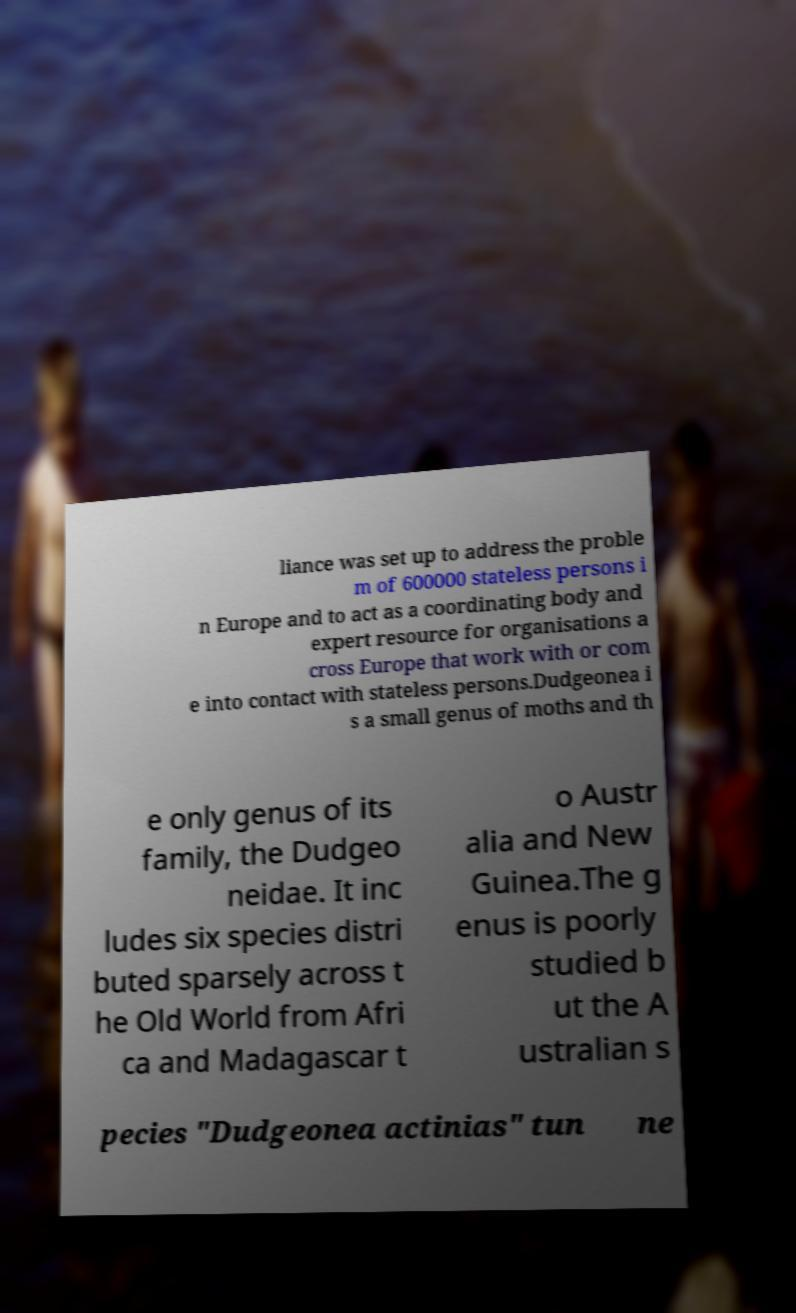Could you extract and type out the text from this image? liance was set up to address the proble m of 600000 stateless persons i n Europe and to act as a coordinating body and expert resource for organisations a cross Europe that work with or com e into contact with stateless persons.Dudgeonea i s a small genus of moths and th e only genus of its family, the Dudgeo neidae. It inc ludes six species distri buted sparsely across t he Old World from Afri ca and Madagascar t o Austr alia and New Guinea.The g enus is poorly studied b ut the A ustralian s pecies "Dudgeonea actinias" tun ne 